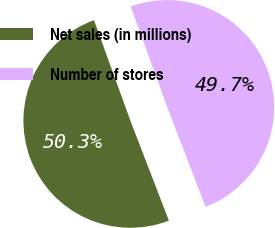Convert chart to OTSL. <chart><loc_0><loc_0><loc_500><loc_500><pie_chart><fcel>Net sales (in millions)<fcel>Number of stores<nl><fcel>50.32%<fcel>49.68%<nl></chart> 